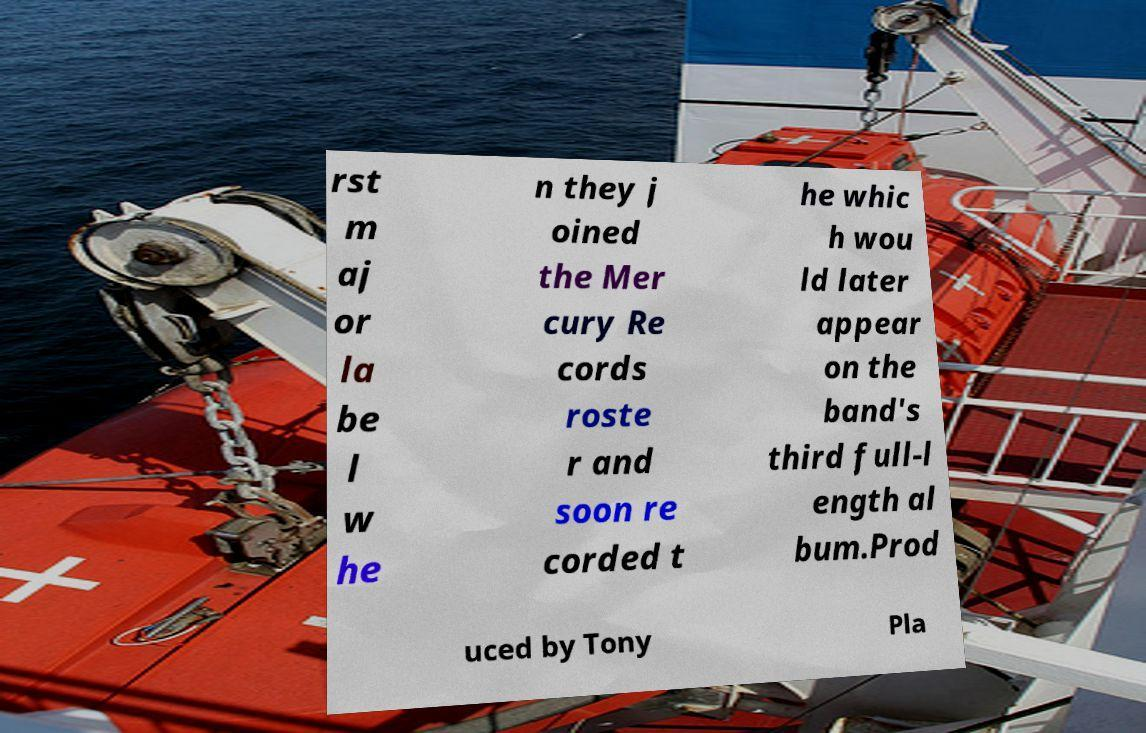Please read and relay the text visible in this image. What does it say? rst m aj or la be l w he n they j oined the Mer cury Re cords roste r and soon re corded t he whic h wou ld later appear on the band's third full-l ength al bum.Prod uced by Tony Pla 